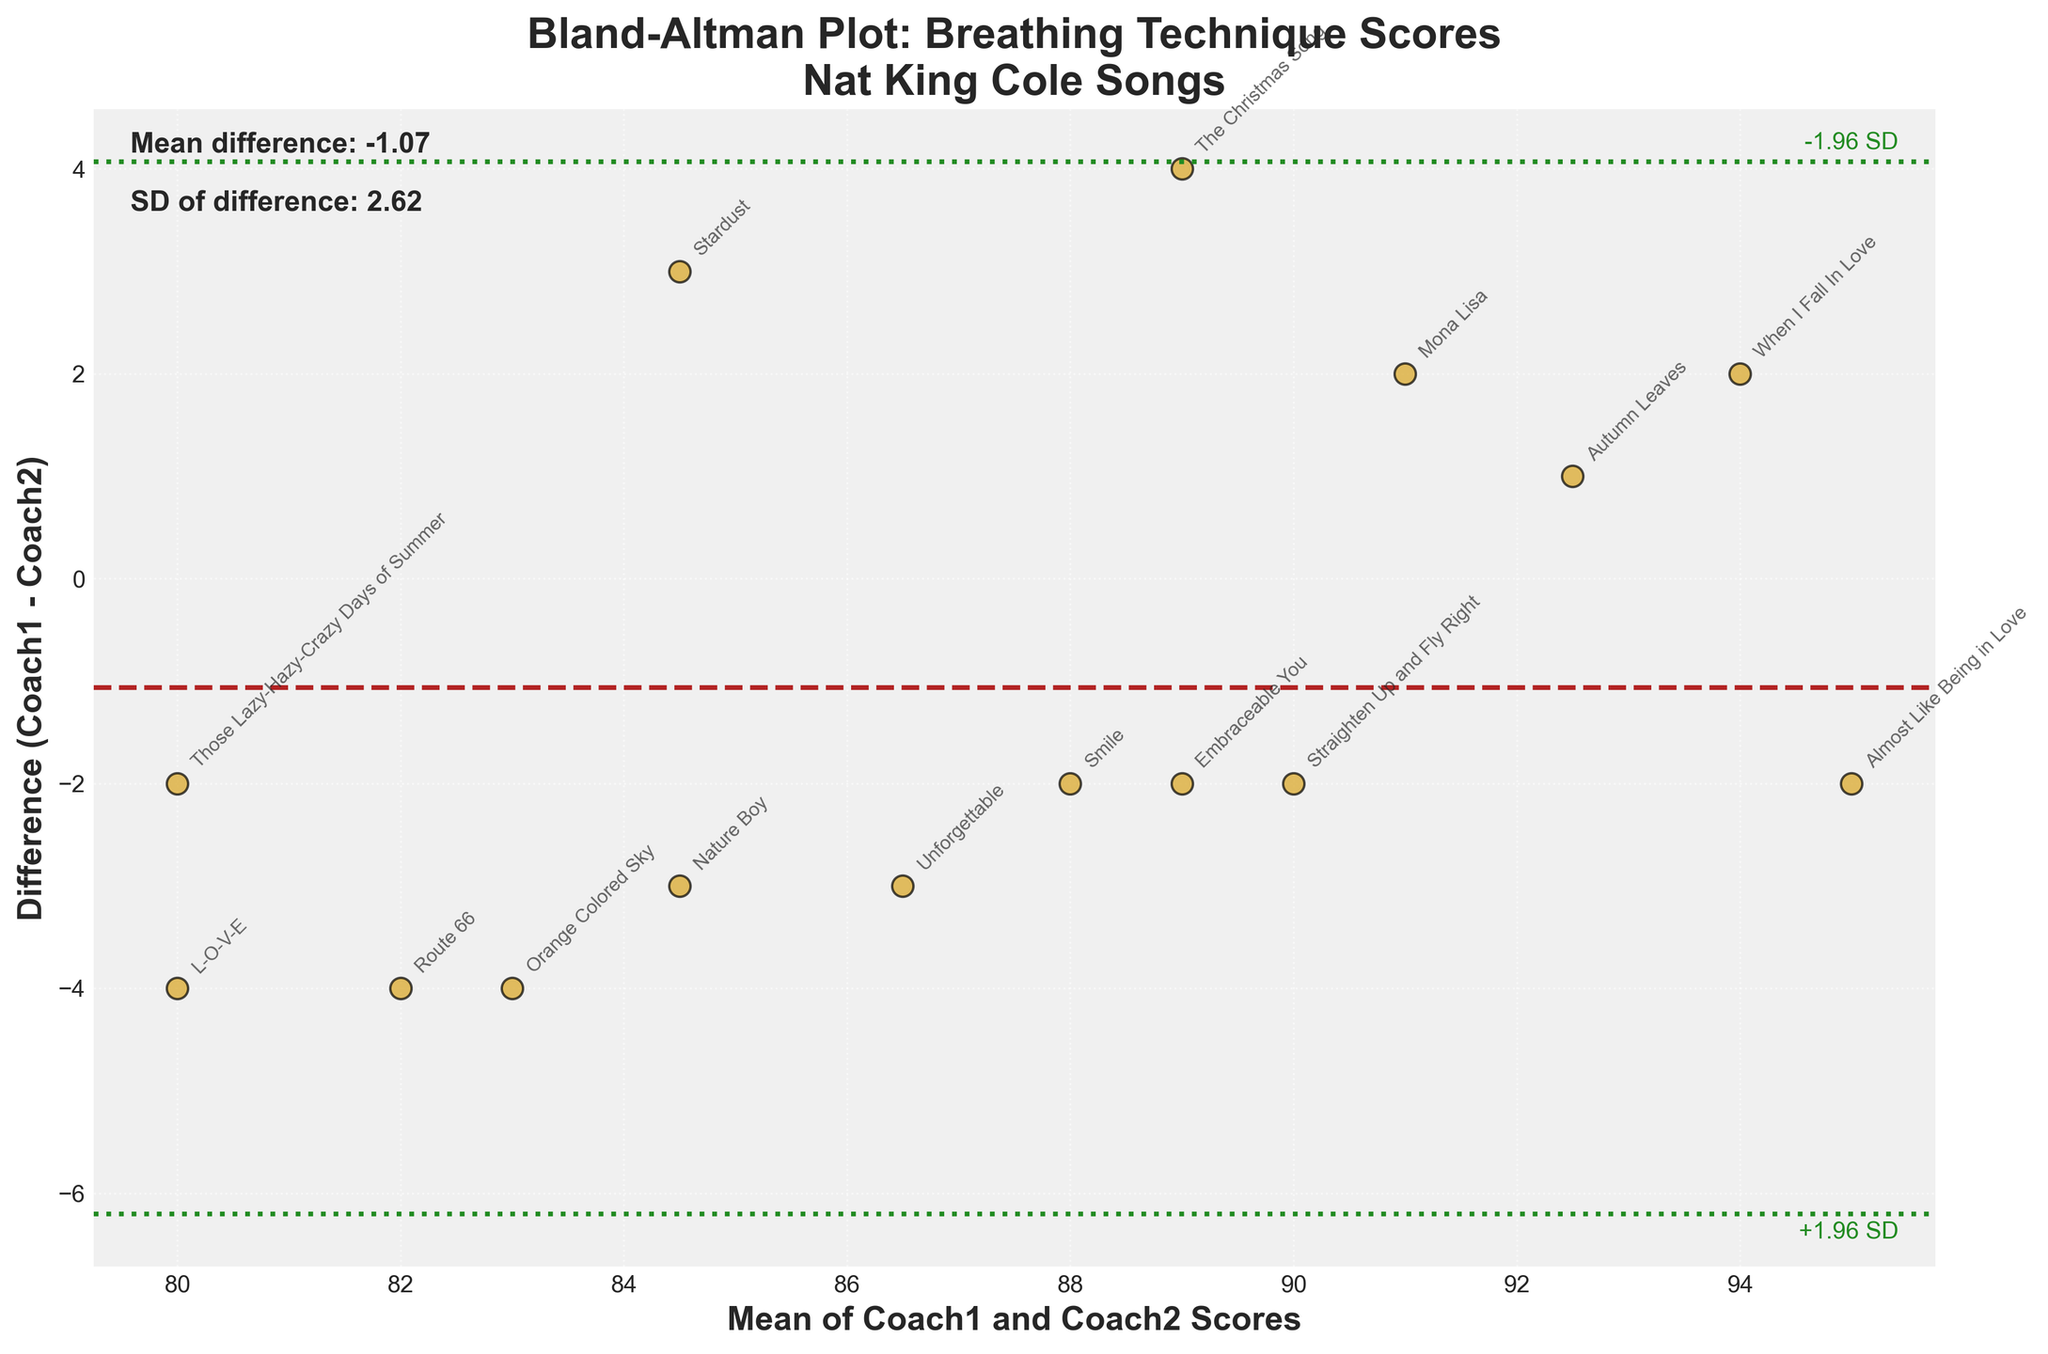What is the title of the plot? The title of the plot is located at the top and reads "Bland-Altman Plot: Breathing Technique Scores\nNat King Cole Songs"
Answer: Bland-Altman Plot: Breathing Technique Scores\nNat King Cole Songs How many data points are on the plot? The plot includes one point for each song listed in the data, and there are 15 songs in total, which gives 15 data points on the plot.
Answer: 15 What color are the data points? The data points are colored in goldenrod, which is a shade of yellow-orange.
Answer: goldenrod Where is the mean difference line located on the plot? The mean difference line is located at a y-axis value where the value of the mean of the differences between Coach1 and Coach2 scores is marked, and it runs horizontally across the plot.
Answer: At the mean difference value Which song has the highest positive difference between Coach1 and Coach2 scores? Look for the data point highest above the mean difference line and read the label next to it. The song with the highest positive difference is "The Christmas Song".
Answer: The Christmas Song What are the values for the +1.96 SD and -1.96 SD lines? The lines are located at mean difference ± (1.96 * SD), which should be visible on the plot. Calculate using the mean and SD values noted on the plot.
Answer: Values derived from ± 1.96 * SD What is the largest difference between scores for the song with the highest mean score? Identify the song with the highest mean score by checking the x-axis and find its difference score on the y-axis. "Almost Like Being in Love" has the highest mean score, and its difference is 2.
Answer: 2 Which song shows the lowest mean score? Look at the data point corresponding to the lowest x-axis value, representing the mean score of Coach1 and Coach2. The song is "Those Lazy-Hazy-Crazy Days of Summer".
Answer: Those Lazy-Hazy-Crazy Days of Summer How is the spread of differences distributed around the mean difference line? Observe how the data points are situated above and below the mean difference line (dashed). Most points seem spread closely around the mean difference.
Answer: Relatively even distribution around the mean Are there any data points outside the ±1.96 SD lines? If so, which song(s)? Check visually if there are any points above the top dotted line or below the bottom dotted line. In this plot, all points appear within the ±1.96 SD range.
Answer: No, all points are within range 